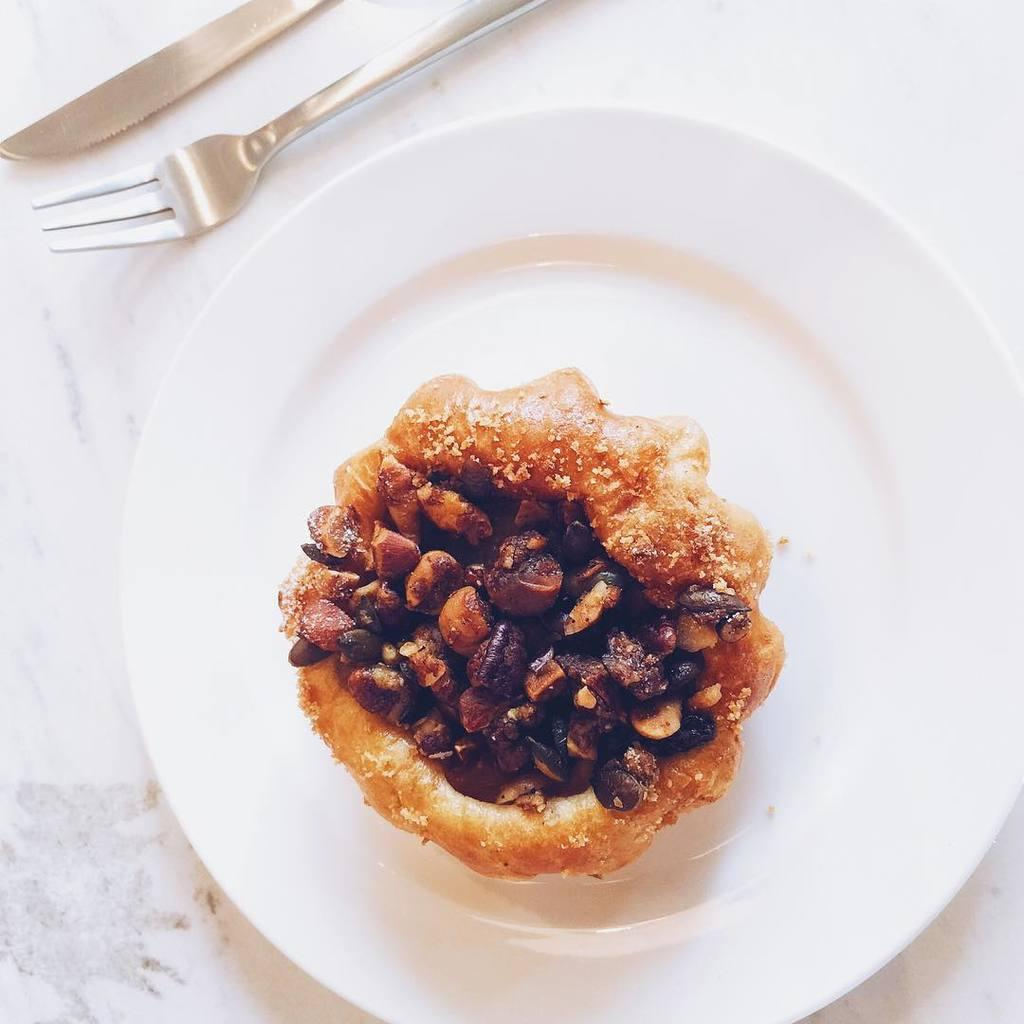What is on the white plate in the image? There is food on a white plate in the image. What is the color of the surface the plate is placed on? The white plate is placed on a white surface. What utensils are visible in the image? A knife and fork are visible at the top of the image. What time is shown on the clock in the image? There is no clock present in the image, so it is not possible to determine the time. 